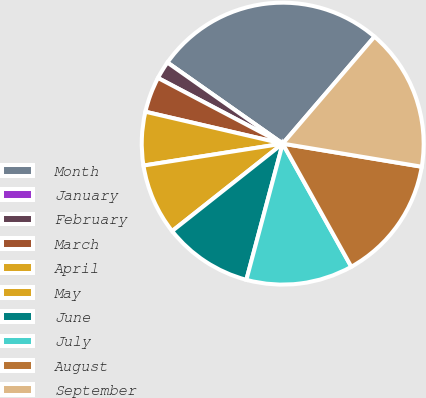Convert chart to OTSL. <chart><loc_0><loc_0><loc_500><loc_500><pie_chart><fcel>Month<fcel>January<fcel>February<fcel>March<fcel>April<fcel>May<fcel>June<fcel>July<fcel>August<fcel>September<nl><fcel>26.53%<fcel>0.0%<fcel>2.04%<fcel>4.08%<fcel>6.12%<fcel>8.16%<fcel>10.2%<fcel>12.24%<fcel>14.29%<fcel>16.33%<nl></chart> 